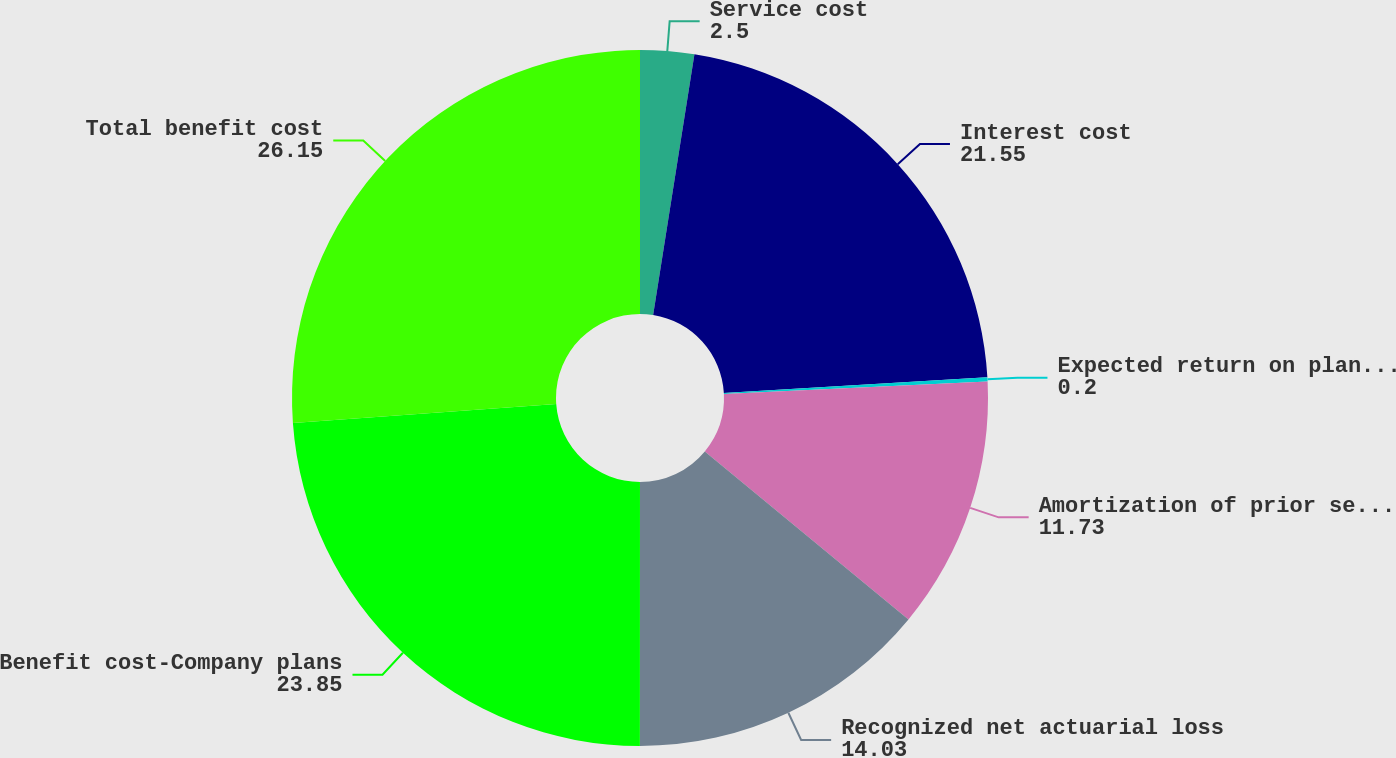Convert chart to OTSL. <chart><loc_0><loc_0><loc_500><loc_500><pie_chart><fcel>Service cost<fcel>Interest cost<fcel>Expected return on plan assets<fcel>Amortization of prior service<fcel>Recognized net actuarial loss<fcel>Benefit cost-Company plans<fcel>Total benefit cost<nl><fcel>2.5%<fcel>21.55%<fcel>0.2%<fcel>11.73%<fcel>14.03%<fcel>23.85%<fcel>26.15%<nl></chart> 